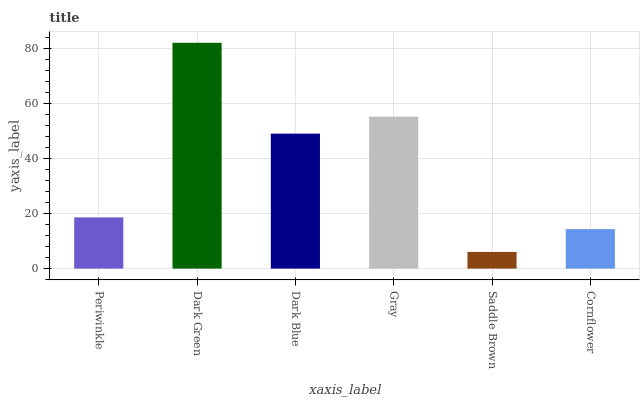Is Saddle Brown the minimum?
Answer yes or no. Yes. Is Dark Green the maximum?
Answer yes or no. Yes. Is Dark Blue the minimum?
Answer yes or no. No. Is Dark Blue the maximum?
Answer yes or no. No. Is Dark Green greater than Dark Blue?
Answer yes or no. Yes. Is Dark Blue less than Dark Green?
Answer yes or no. Yes. Is Dark Blue greater than Dark Green?
Answer yes or no. No. Is Dark Green less than Dark Blue?
Answer yes or no. No. Is Dark Blue the high median?
Answer yes or no. Yes. Is Periwinkle the low median?
Answer yes or no. Yes. Is Saddle Brown the high median?
Answer yes or no. No. Is Cornflower the low median?
Answer yes or no. No. 